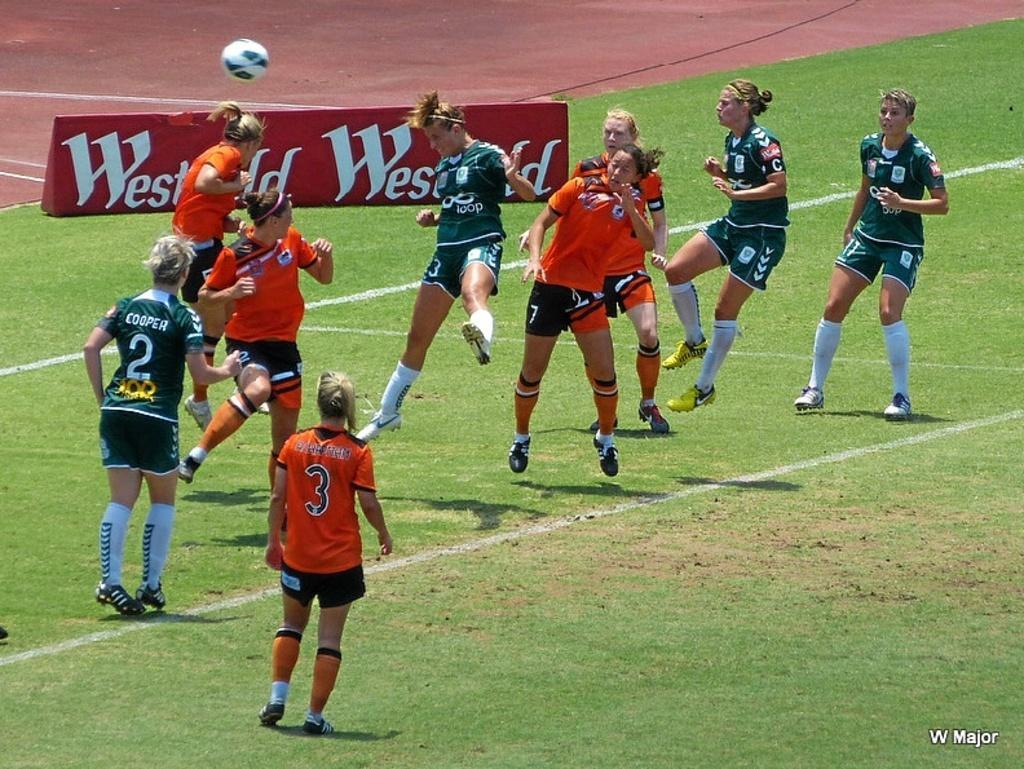Could you give a brief overview of what you see in this image? This image is taken outdoors. At the bottom of the image there is a ground with grass on it. In the background there is a board with a text on it. In the middle of the image a few women are playing football on the ground and there is a ball. 